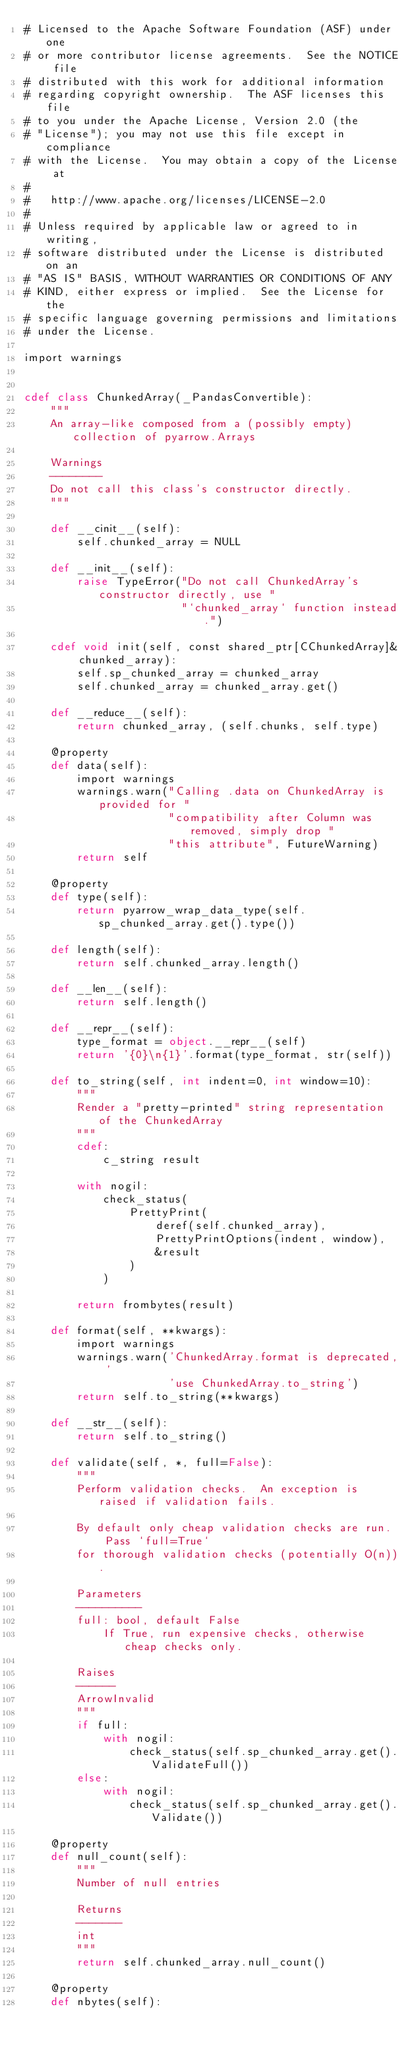<code> <loc_0><loc_0><loc_500><loc_500><_Cython_># Licensed to the Apache Software Foundation (ASF) under one
# or more contributor license agreements.  See the NOTICE file
# distributed with this work for additional information
# regarding copyright ownership.  The ASF licenses this file
# to you under the Apache License, Version 2.0 (the
# "License"); you may not use this file except in compliance
# with the License.  You may obtain a copy of the License at
#
#   http://www.apache.org/licenses/LICENSE-2.0
#
# Unless required by applicable law or agreed to in writing,
# software distributed under the License is distributed on an
# "AS IS" BASIS, WITHOUT WARRANTIES OR CONDITIONS OF ANY
# KIND, either express or implied.  See the License for the
# specific language governing permissions and limitations
# under the License.

import warnings


cdef class ChunkedArray(_PandasConvertible):
    """
    An array-like composed from a (possibly empty) collection of pyarrow.Arrays

    Warnings
    --------
    Do not call this class's constructor directly.
    """

    def __cinit__(self):
        self.chunked_array = NULL

    def __init__(self):
        raise TypeError("Do not call ChunkedArray's constructor directly, use "
                        "`chunked_array` function instead.")

    cdef void init(self, const shared_ptr[CChunkedArray]& chunked_array):
        self.sp_chunked_array = chunked_array
        self.chunked_array = chunked_array.get()

    def __reduce__(self):
        return chunked_array, (self.chunks, self.type)

    @property
    def data(self):
        import warnings
        warnings.warn("Calling .data on ChunkedArray is provided for "
                      "compatibility after Column was removed, simply drop "
                      "this attribute", FutureWarning)
        return self

    @property
    def type(self):
        return pyarrow_wrap_data_type(self.sp_chunked_array.get().type())

    def length(self):
        return self.chunked_array.length()

    def __len__(self):
        return self.length()

    def __repr__(self):
        type_format = object.__repr__(self)
        return '{0}\n{1}'.format(type_format, str(self))

    def to_string(self, int indent=0, int window=10):
        """
        Render a "pretty-printed" string representation of the ChunkedArray
        """
        cdef:
            c_string result

        with nogil:
            check_status(
                PrettyPrint(
                    deref(self.chunked_array),
                    PrettyPrintOptions(indent, window),
                    &result
                )
            )

        return frombytes(result)

    def format(self, **kwargs):
        import warnings
        warnings.warn('ChunkedArray.format is deprecated, '
                      'use ChunkedArray.to_string')
        return self.to_string(**kwargs)

    def __str__(self):
        return self.to_string()

    def validate(self, *, full=False):
        """
        Perform validation checks.  An exception is raised if validation fails.

        By default only cheap validation checks are run.  Pass `full=True`
        for thorough validation checks (potentially O(n)).

        Parameters
        ----------
        full: bool, default False
            If True, run expensive checks, otherwise cheap checks only.

        Raises
        ------
        ArrowInvalid
        """
        if full:
            with nogil:
                check_status(self.sp_chunked_array.get().ValidateFull())
        else:
            with nogil:
                check_status(self.sp_chunked_array.get().Validate())

    @property
    def null_count(self):
        """
        Number of null entries

        Returns
        -------
        int
        """
        return self.chunked_array.null_count()

    @property
    def nbytes(self):</code> 